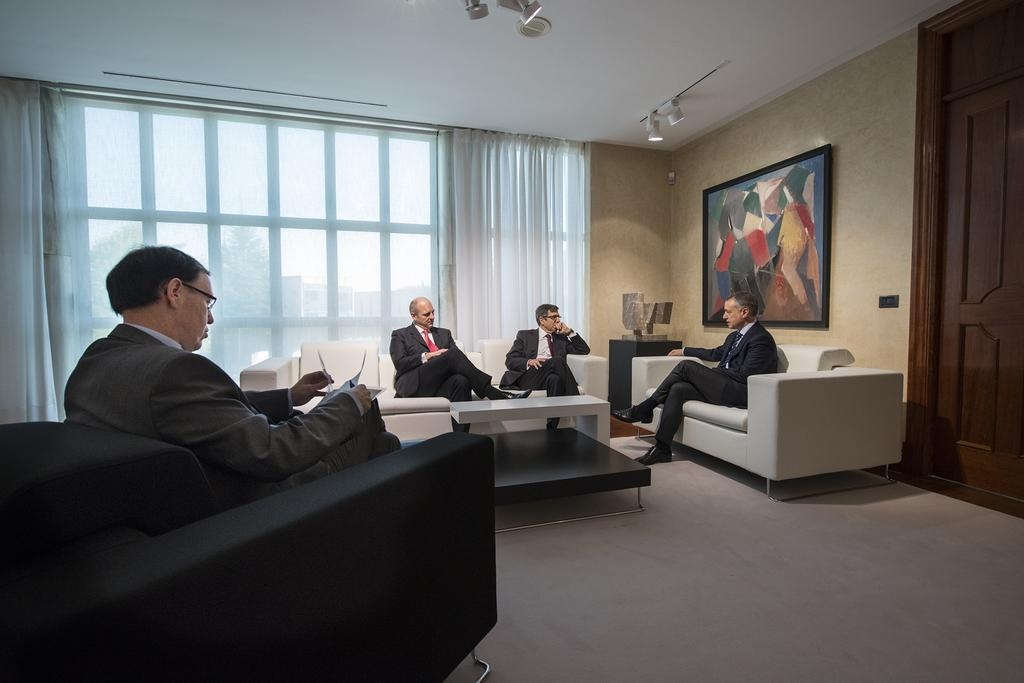What are the people in the image doing? The people in the image are sitting in a room. What are the people sitting on? The people are sitting on chairs. What is in front of the chairs? There is a table in front of the chairs. What can be seen on the wall in the room? There is a frame on the wall in the room. What statement can be seen written on the window in the image? There is no window present in the image, and therefore no statement can be seen written on it. 